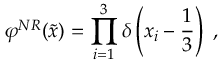Convert formula to latex. <formula><loc_0><loc_0><loc_500><loc_500>\varphi ^ { N R } ( \tilde { x } ) = \prod _ { i = 1 } ^ { 3 } \delta \left ( x _ { i } - \frac { 1 } { 3 } \right ) \, ,</formula> 